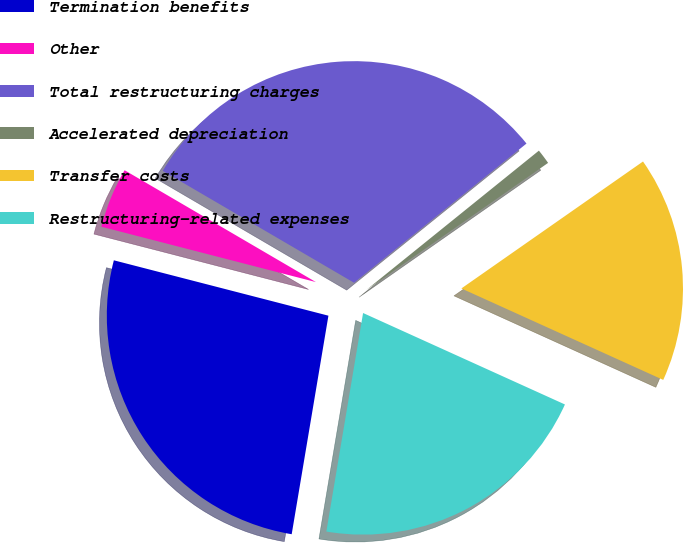<chart> <loc_0><loc_0><loc_500><loc_500><pie_chart><fcel>Termination benefits<fcel>Other<fcel>Total restructuring charges<fcel>Accelerated depreciation<fcel>Transfer costs<fcel>Restructuring-related expenses<nl><fcel>26.37%<fcel>4.4%<fcel>30.77%<fcel>1.1%<fcel>16.48%<fcel>20.88%<nl></chart> 